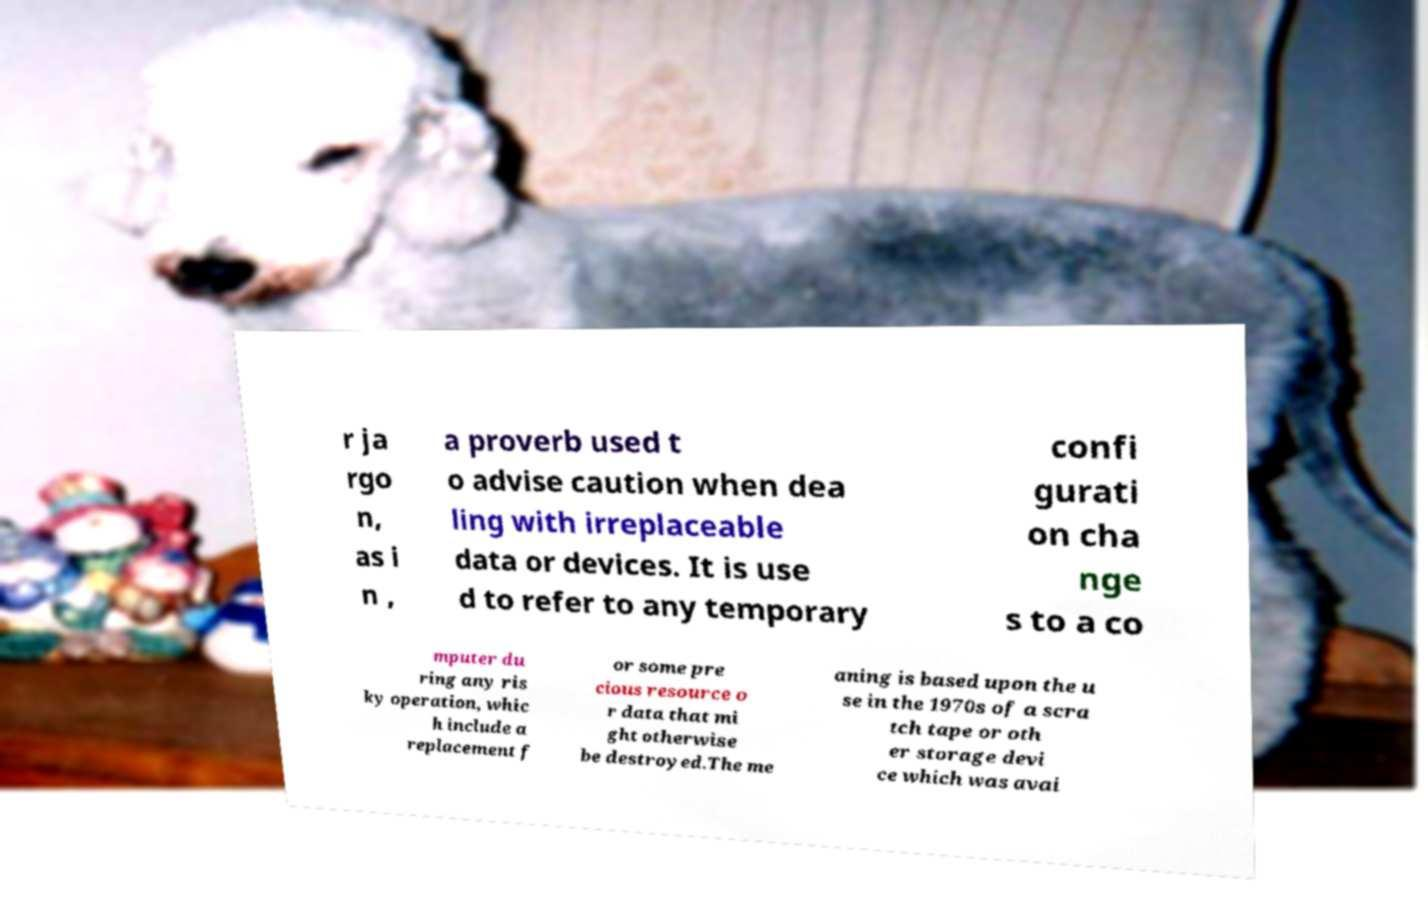Can you accurately transcribe the text from the provided image for me? r ja rgo n, as i n , a proverb used t o advise caution when dea ling with irreplaceable data or devices. It is use d to refer to any temporary confi gurati on cha nge s to a co mputer du ring any ris ky operation, whic h include a replacement f or some pre cious resource o r data that mi ght otherwise be destroyed.The me aning is based upon the u se in the 1970s of a scra tch tape or oth er storage devi ce which was avai 